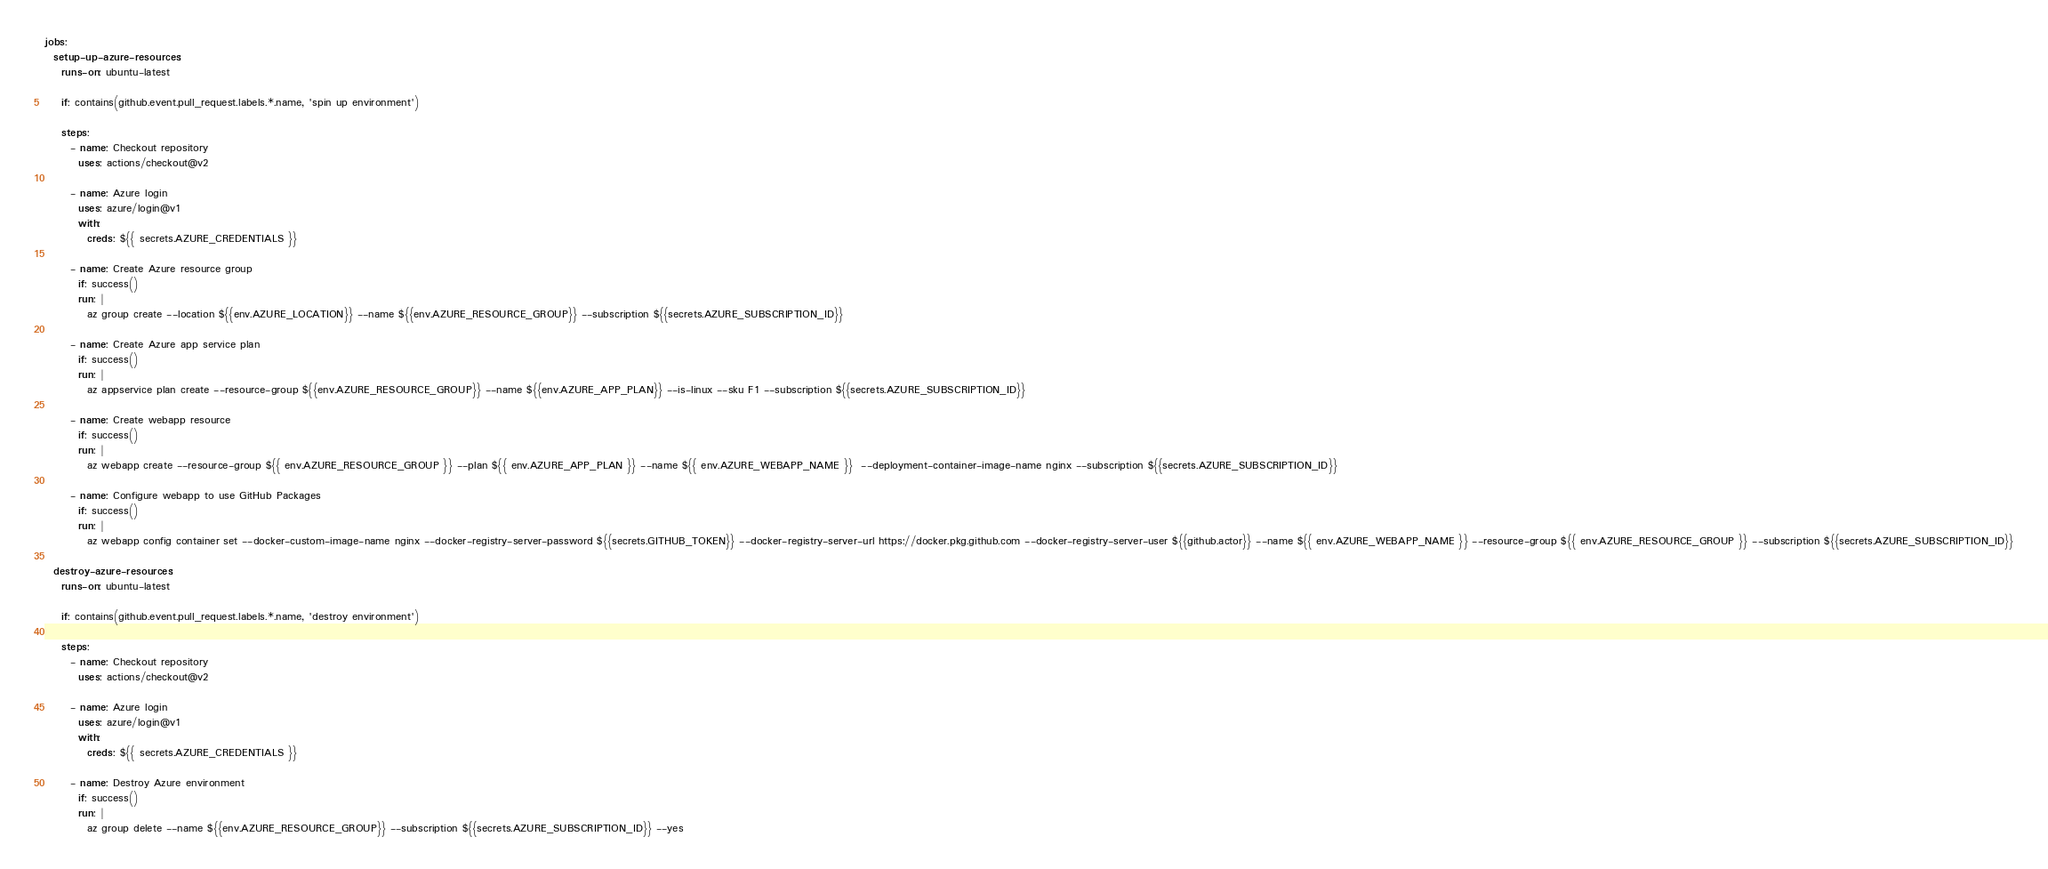<code> <loc_0><loc_0><loc_500><loc_500><_YAML_>jobs:
  setup-up-azure-resources:
    runs-on: ubuntu-latest

    if: contains(github.event.pull_request.labels.*.name, 'spin up environment')

    steps:
      - name: Checkout repository
        uses: actions/checkout@v2

      - name: Azure login
        uses: azure/login@v1
        with:
          creds: ${{ secrets.AZURE_CREDENTIALS }}

      - name: Create Azure resource group
        if: success()
        run: |
          az group create --location ${{env.AZURE_LOCATION}} --name ${{env.AZURE_RESOURCE_GROUP}} --subscription ${{secrets.AZURE_SUBSCRIPTION_ID}}

      - name: Create Azure app service plan
        if: success()
        run: |
          az appservice plan create --resource-group ${{env.AZURE_RESOURCE_GROUP}} --name ${{env.AZURE_APP_PLAN}} --is-linux --sku F1 --subscription ${{secrets.AZURE_SUBSCRIPTION_ID}}

      - name: Create webapp resource
        if: success()
        run: |
          az webapp create --resource-group ${{ env.AZURE_RESOURCE_GROUP }} --plan ${{ env.AZURE_APP_PLAN }} --name ${{ env.AZURE_WEBAPP_NAME }}  --deployment-container-image-name nginx --subscription ${{secrets.AZURE_SUBSCRIPTION_ID}}

      - name: Configure webapp to use GitHub Packages
        if: success()
        run: |
          az webapp config container set --docker-custom-image-name nginx --docker-registry-server-password ${{secrets.GITHUB_TOKEN}} --docker-registry-server-url https://docker.pkg.github.com --docker-registry-server-user ${{github.actor}} --name ${{ env.AZURE_WEBAPP_NAME }} --resource-group ${{ env.AZURE_RESOURCE_GROUP }} --subscription ${{secrets.AZURE_SUBSCRIPTION_ID}}

  destroy-azure-resources:
    runs-on: ubuntu-latest

    if: contains(github.event.pull_request.labels.*.name, 'destroy environment')

    steps:
      - name: Checkout repository
        uses: actions/checkout@v2

      - name: Azure login
        uses: azure/login@v1
        with:
          creds: ${{ secrets.AZURE_CREDENTIALS }}

      - name: Destroy Azure environment
        if: success()
        run: |
          az group delete --name ${{env.AZURE_RESOURCE_GROUP}} --subscription ${{secrets.AZURE_SUBSCRIPTION_ID}} --yes
</code> 